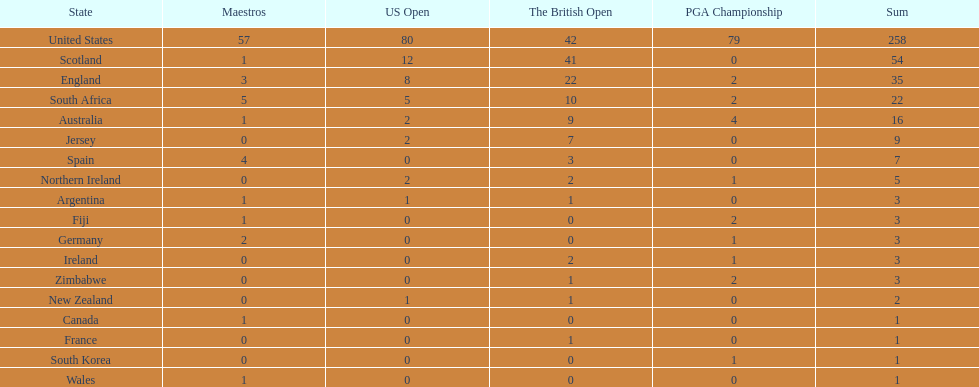How many total championships does spain have? 7. 